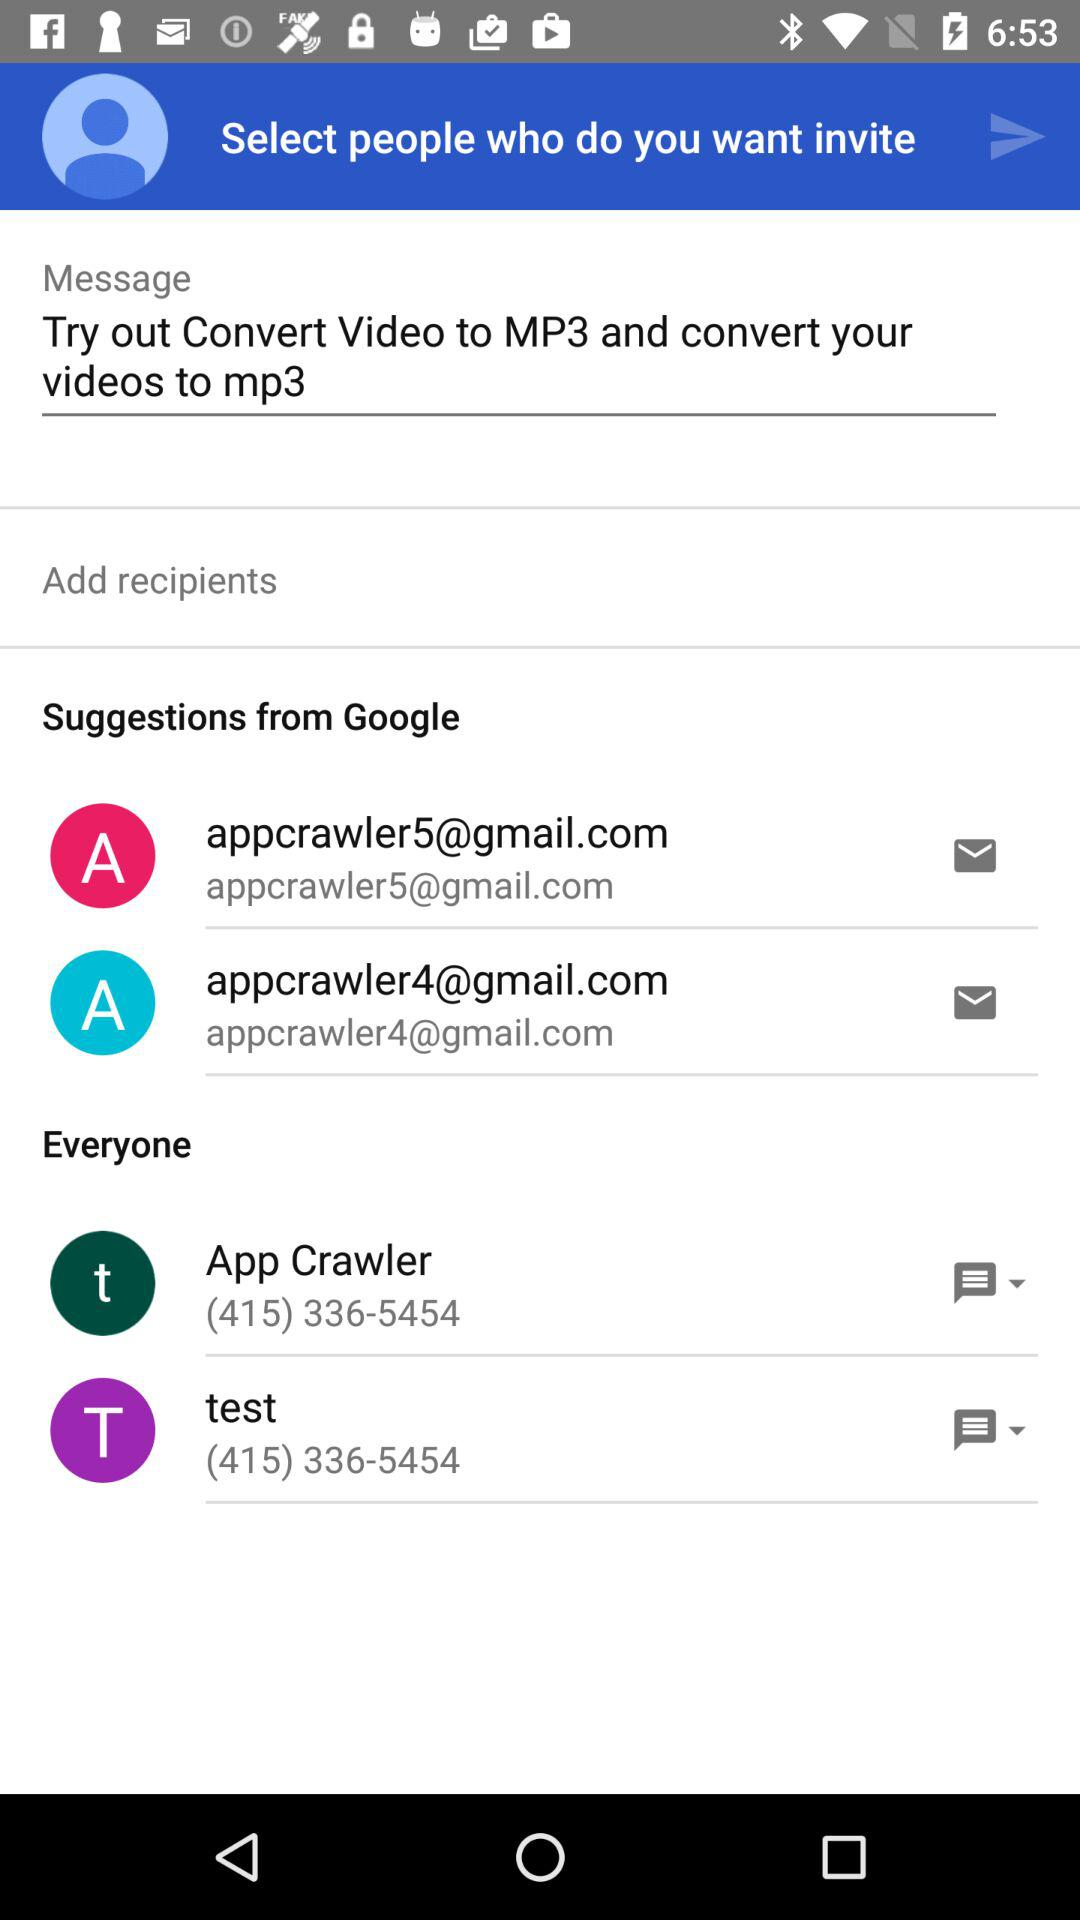How many recipients are suggested?
Answer the question using a single word or phrase. 2 